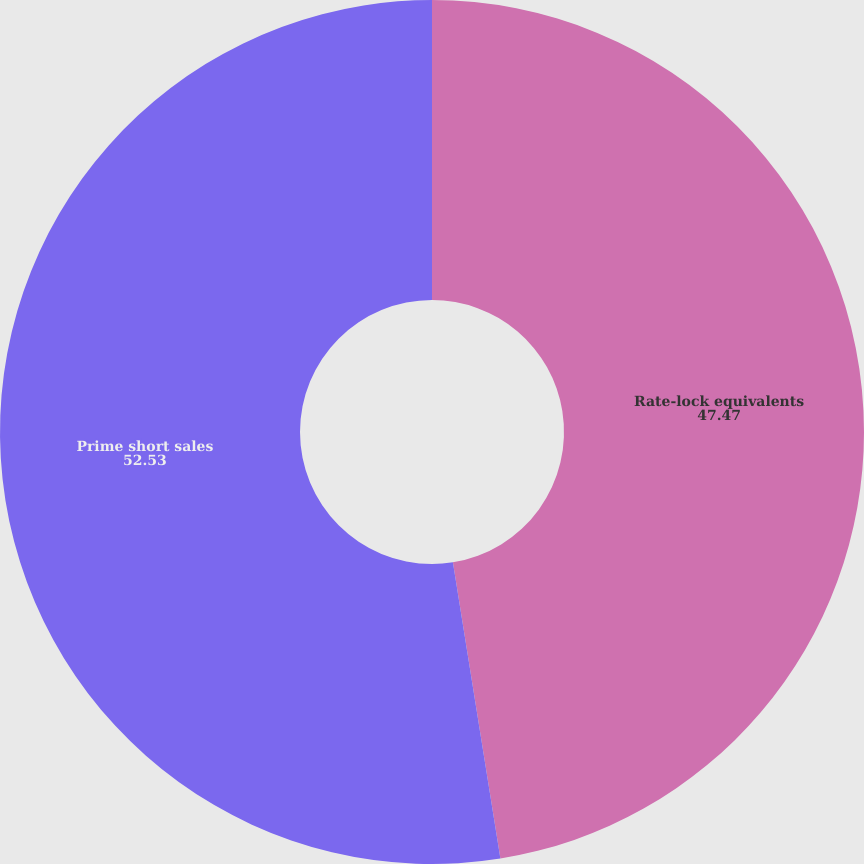Convert chart to OTSL. <chart><loc_0><loc_0><loc_500><loc_500><pie_chart><fcel>Rate-lock equivalents<fcel>Prime short sales<nl><fcel>47.47%<fcel>52.53%<nl></chart> 